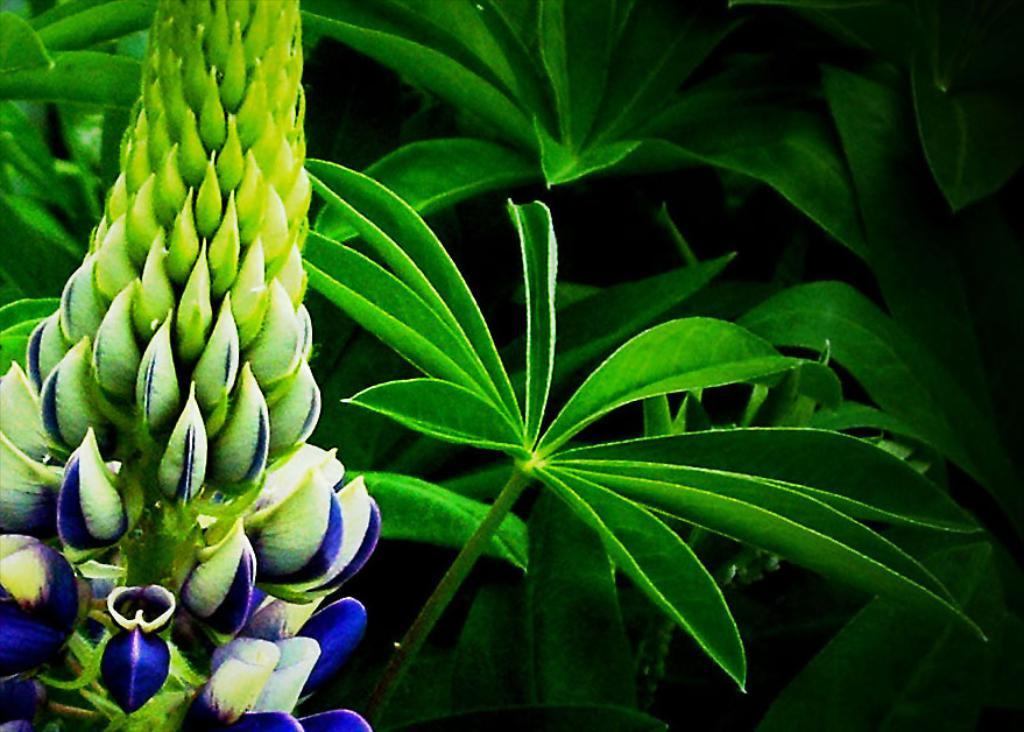What is the main subject of the image? The main subject of the image is a group of plants. Can you describe the plants in the image? Unfortunately, the facts provided do not give any specific details about the plants. Are there any other objects or elements in the image besides the plants? The facts provided do not mention any other objects or elements in the image. What is the weight of the chair in the image? There is no chair present in the image, so it is not possible to determine its weight. 